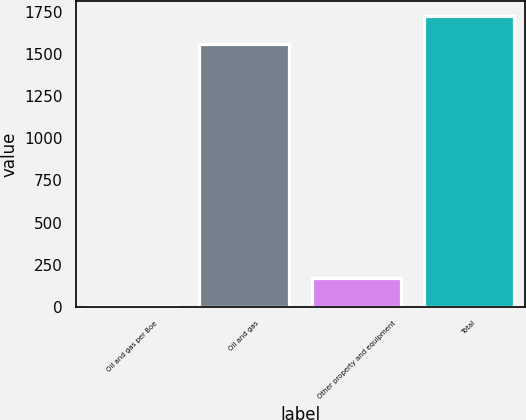Convert chart to OTSL. <chart><loc_0><loc_0><loc_500><loc_500><bar_chart><fcel>Oil and gas per Boe<fcel>Oil and gas<fcel>Other property and equipment<fcel>Total<nl><fcel>7.98<fcel>1559<fcel>172.98<fcel>1724<nl></chart> 